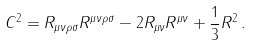<formula> <loc_0><loc_0><loc_500><loc_500>C ^ { 2 } = R _ { \mu \nu \rho \sigma } R ^ { \mu \nu \rho \sigma } - 2 R _ { \mu \nu } R ^ { \mu \nu } + \frac { 1 } { 3 } R ^ { 2 } \, .</formula> 